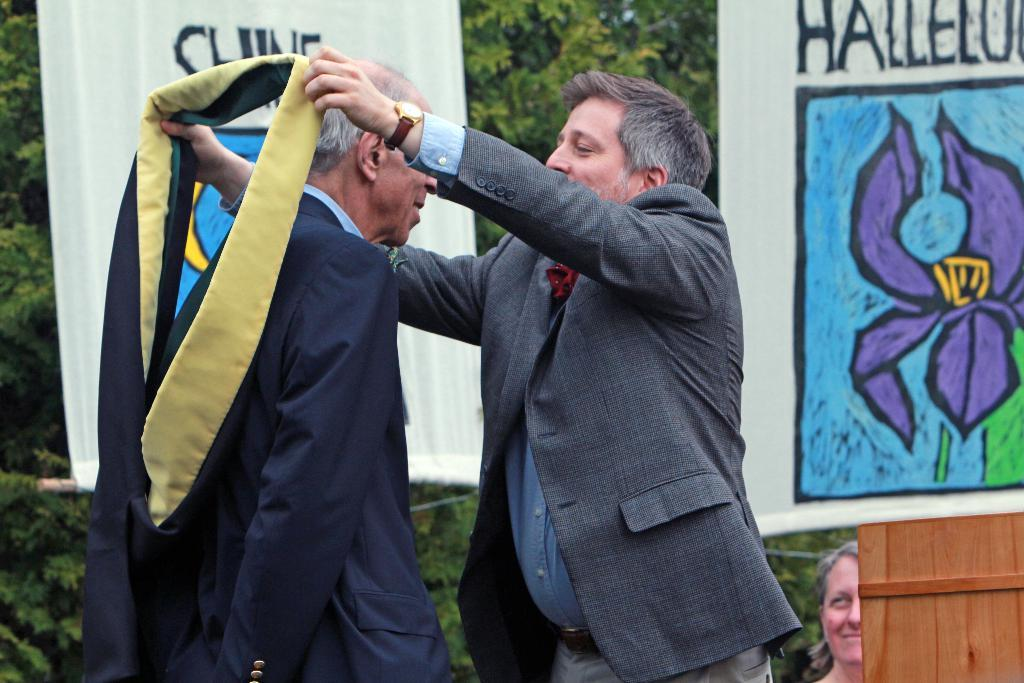How many people are present in the image? There are two men and one woman in the image, making a total of three people. What can be seen on the walls or surfaces in the image? There are posters visible in the image. Can you describe the natural elements in the image? There are plants and trees in the image. What type of twig is being used as a yoke in the image? There is no twig or yoke present in the image. 